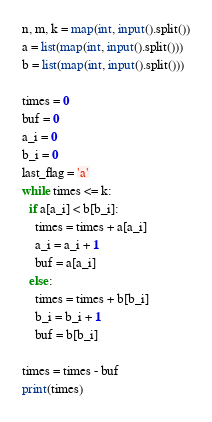Convert code to text. <code><loc_0><loc_0><loc_500><loc_500><_Python_>n, m, k = map(int, input().split())
a = list(map(int, input().split()))
b = list(map(int, input().split()))

times = 0
buf = 0
a_i = 0
b_i = 0
last_flag = 'a'
while times <= k:
  if a[a_i] < b[b_i]:
    times = times + a[a_i]
    a_i = a_i + 1
    buf = a[a_i]
  else:
    times = times + b[b_i]
    b_i = b_i + 1
    buf = b[b_i]

times = times - buf
print(times)
</code> 